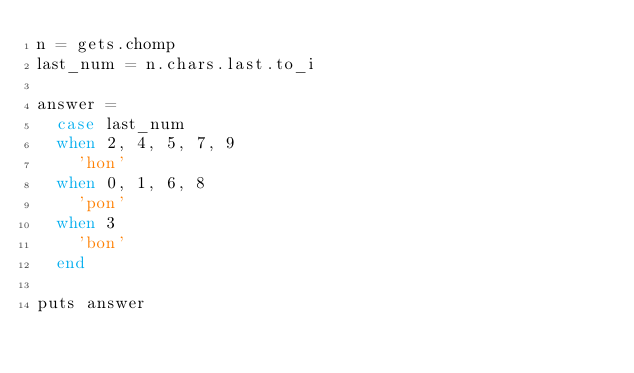<code> <loc_0><loc_0><loc_500><loc_500><_Ruby_>n = gets.chomp
last_num = n.chars.last.to_i

answer =
  case last_num
  when 2, 4, 5, 7, 9
    'hon'
  when 0, 1, 6, 8
    'pon'
  when 3
    'bon'
  end

puts answer
</code> 